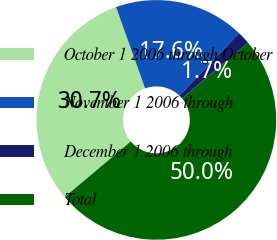<chart> <loc_0><loc_0><loc_500><loc_500><pie_chart><fcel>October 1 2006 through October<fcel>November 1 2006 through<fcel>December 1 2006 through<fcel>Total<nl><fcel>30.67%<fcel>17.59%<fcel>1.74%<fcel>50.0%<nl></chart> 